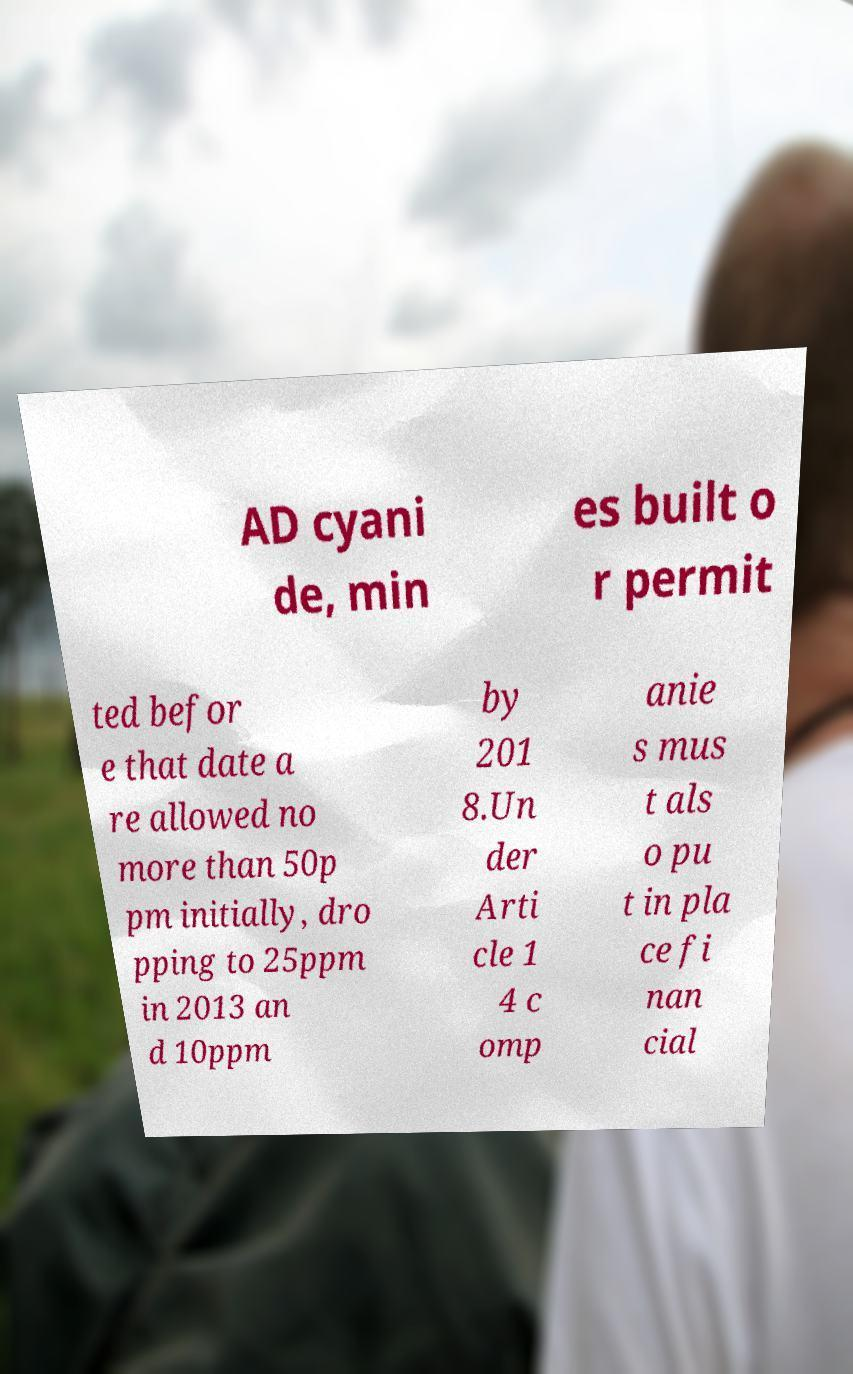Could you extract and type out the text from this image? AD cyani de, min es built o r permit ted befor e that date a re allowed no more than 50p pm initially, dro pping to 25ppm in 2013 an d 10ppm by 201 8.Un der Arti cle 1 4 c omp anie s mus t als o pu t in pla ce fi nan cial 